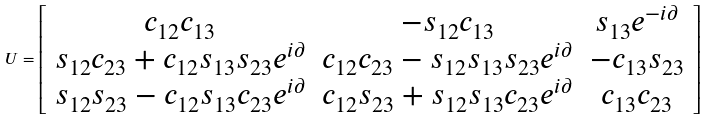Convert formula to latex. <formula><loc_0><loc_0><loc_500><loc_500>U = \left [ \begin{array} { c c c } c _ { 1 2 } c _ { 1 3 } & - s _ { 1 2 } c _ { 1 3 } & s _ { 1 3 } e ^ { - i \partial } \\ s _ { 1 2 } c _ { 2 3 } + c _ { 1 2 } s _ { 1 3 } s _ { 2 3 } e ^ { i \partial } & c _ { 1 2 } c _ { 2 3 } - s _ { 1 2 } s _ { 1 3 } s _ { 2 3 } e ^ { i \partial } & - c _ { 1 3 } s _ { 2 3 } \\ s _ { 1 2 } s _ { 2 3 } - c _ { 1 2 } s _ { 1 3 } c _ { 2 3 } e ^ { i \partial } & c _ { 1 2 } s _ { 2 3 } + s _ { 1 2 } s _ { 1 3 } c _ { 2 3 } e ^ { i \partial } & c _ { 1 3 } c _ { 2 3 } \end{array} \right ]</formula> 